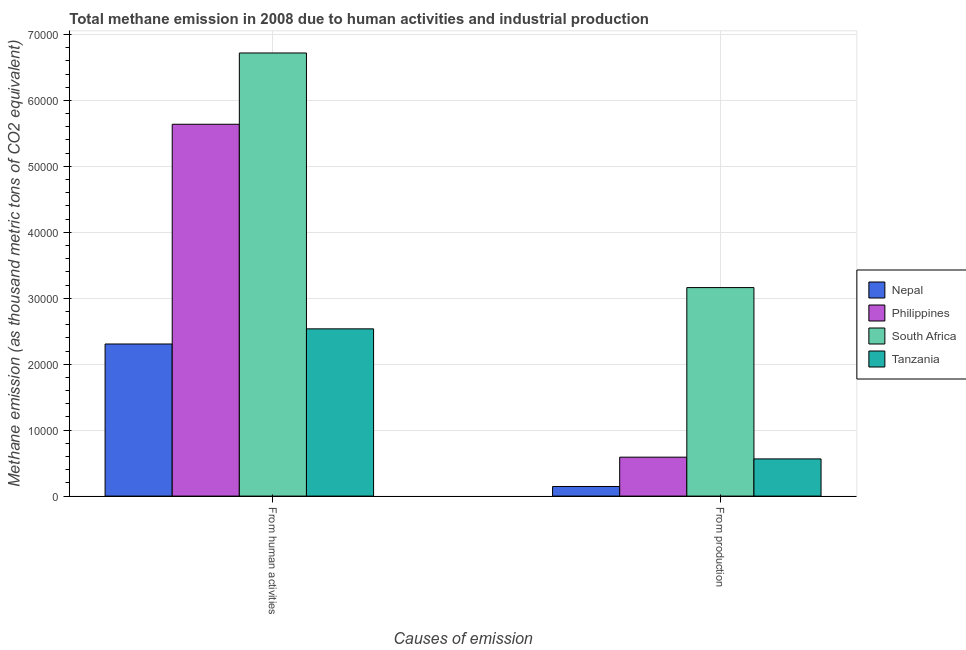How many different coloured bars are there?
Your answer should be compact. 4. Are the number of bars per tick equal to the number of legend labels?
Provide a succinct answer. Yes. Are the number of bars on each tick of the X-axis equal?
Offer a terse response. Yes. What is the label of the 2nd group of bars from the left?
Your answer should be very brief. From production. What is the amount of emissions from human activities in South Africa?
Provide a succinct answer. 6.72e+04. Across all countries, what is the maximum amount of emissions generated from industries?
Offer a terse response. 3.16e+04. Across all countries, what is the minimum amount of emissions from human activities?
Your answer should be compact. 2.31e+04. In which country was the amount of emissions from human activities maximum?
Offer a very short reply. South Africa. In which country was the amount of emissions generated from industries minimum?
Provide a succinct answer. Nepal. What is the total amount of emissions generated from industries in the graph?
Keep it short and to the point. 4.46e+04. What is the difference between the amount of emissions from human activities in Nepal and that in Philippines?
Your answer should be very brief. -3.33e+04. What is the difference between the amount of emissions from human activities in South Africa and the amount of emissions generated from industries in Nepal?
Provide a succinct answer. 6.57e+04. What is the average amount of emissions from human activities per country?
Keep it short and to the point. 4.30e+04. What is the difference between the amount of emissions generated from industries and amount of emissions from human activities in Philippines?
Make the answer very short. -5.05e+04. What is the ratio of the amount of emissions from human activities in South Africa to that in Tanzania?
Ensure brevity in your answer.  2.65. In how many countries, is the amount of emissions generated from industries greater than the average amount of emissions generated from industries taken over all countries?
Your answer should be very brief. 1. What does the 4th bar from the left in From human activities represents?
Make the answer very short. Tanzania. What does the 4th bar from the right in From human activities represents?
Keep it short and to the point. Nepal. Are all the bars in the graph horizontal?
Your answer should be compact. No. What is the difference between two consecutive major ticks on the Y-axis?
Keep it short and to the point. 10000. Are the values on the major ticks of Y-axis written in scientific E-notation?
Ensure brevity in your answer.  No. Does the graph contain grids?
Your answer should be very brief. Yes. Where does the legend appear in the graph?
Make the answer very short. Center right. How many legend labels are there?
Make the answer very short. 4. What is the title of the graph?
Keep it short and to the point. Total methane emission in 2008 due to human activities and industrial production. Does "Myanmar" appear as one of the legend labels in the graph?
Offer a very short reply. No. What is the label or title of the X-axis?
Keep it short and to the point. Causes of emission. What is the label or title of the Y-axis?
Your answer should be compact. Methane emission (as thousand metric tons of CO2 equivalent). What is the Methane emission (as thousand metric tons of CO2 equivalent) of Nepal in From human activities?
Provide a succinct answer. 2.31e+04. What is the Methane emission (as thousand metric tons of CO2 equivalent) in Philippines in From human activities?
Your answer should be very brief. 5.64e+04. What is the Methane emission (as thousand metric tons of CO2 equivalent) in South Africa in From human activities?
Provide a succinct answer. 6.72e+04. What is the Methane emission (as thousand metric tons of CO2 equivalent) of Tanzania in From human activities?
Ensure brevity in your answer.  2.54e+04. What is the Methane emission (as thousand metric tons of CO2 equivalent) of Nepal in From production?
Your response must be concise. 1458.6. What is the Methane emission (as thousand metric tons of CO2 equivalent) of Philippines in From production?
Give a very brief answer. 5905.9. What is the Methane emission (as thousand metric tons of CO2 equivalent) of South Africa in From production?
Your answer should be very brief. 3.16e+04. What is the Methane emission (as thousand metric tons of CO2 equivalent) in Tanzania in From production?
Offer a very short reply. 5639.9. Across all Causes of emission, what is the maximum Methane emission (as thousand metric tons of CO2 equivalent) of Nepal?
Offer a terse response. 2.31e+04. Across all Causes of emission, what is the maximum Methane emission (as thousand metric tons of CO2 equivalent) in Philippines?
Your answer should be compact. 5.64e+04. Across all Causes of emission, what is the maximum Methane emission (as thousand metric tons of CO2 equivalent) in South Africa?
Give a very brief answer. 6.72e+04. Across all Causes of emission, what is the maximum Methane emission (as thousand metric tons of CO2 equivalent) of Tanzania?
Offer a very short reply. 2.54e+04. Across all Causes of emission, what is the minimum Methane emission (as thousand metric tons of CO2 equivalent) of Nepal?
Your answer should be very brief. 1458.6. Across all Causes of emission, what is the minimum Methane emission (as thousand metric tons of CO2 equivalent) of Philippines?
Provide a short and direct response. 5905.9. Across all Causes of emission, what is the minimum Methane emission (as thousand metric tons of CO2 equivalent) of South Africa?
Keep it short and to the point. 3.16e+04. Across all Causes of emission, what is the minimum Methane emission (as thousand metric tons of CO2 equivalent) in Tanzania?
Your answer should be compact. 5639.9. What is the total Methane emission (as thousand metric tons of CO2 equivalent) of Nepal in the graph?
Offer a terse response. 2.45e+04. What is the total Methane emission (as thousand metric tons of CO2 equivalent) of Philippines in the graph?
Keep it short and to the point. 6.23e+04. What is the total Methane emission (as thousand metric tons of CO2 equivalent) of South Africa in the graph?
Your response must be concise. 9.88e+04. What is the total Methane emission (as thousand metric tons of CO2 equivalent) of Tanzania in the graph?
Offer a terse response. 3.10e+04. What is the difference between the Methane emission (as thousand metric tons of CO2 equivalent) in Nepal in From human activities and that in From production?
Keep it short and to the point. 2.16e+04. What is the difference between the Methane emission (as thousand metric tons of CO2 equivalent) of Philippines in From human activities and that in From production?
Provide a short and direct response. 5.05e+04. What is the difference between the Methane emission (as thousand metric tons of CO2 equivalent) in South Africa in From human activities and that in From production?
Offer a terse response. 3.56e+04. What is the difference between the Methane emission (as thousand metric tons of CO2 equivalent) of Tanzania in From human activities and that in From production?
Your answer should be compact. 1.97e+04. What is the difference between the Methane emission (as thousand metric tons of CO2 equivalent) of Nepal in From human activities and the Methane emission (as thousand metric tons of CO2 equivalent) of Philippines in From production?
Offer a very short reply. 1.72e+04. What is the difference between the Methane emission (as thousand metric tons of CO2 equivalent) in Nepal in From human activities and the Methane emission (as thousand metric tons of CO2 equivalent) in South Africa in From production?
Keep it short and to the point. -8551.5. What is the difference between the Methane emission (as thousand metric tons of CO2 equivalent) in Nepal in From human activities and the Methane emission (as thousand metric tons of CO2 equivalent) in Tanzania in From production?
Your answer should be compact. 1.74e+04. What is the difference between the Methane emission (as thousand metric tons of CO2 equivalent) in Philippines in From human activities and the Methane emission (as thousand metric tons of CO2 equivalent) in South Africa in From production?
Offer a very short reply. 2.48e+04. What is the difference between the Methane emission (as thousand metric tons of CO2 equivalent) of Philippines in From human activities and the Methane emission (as thousand metric tons of CO2 equivalent) of Tanzania in From production?
Your answer should be compact. 5.07e+04. What is the difference between the Methane emission (as thousand metric tons of CO2 equivalent) of South Africa in From human activities and the Methane emission (as thousand metric tons of CO2 equivalent) of Tanzania in From production?
Offer a very short reply. 6.15e+04. What is the average Methane emission (as thousand metric tons of CO2 equivalent) in Nepal per Causes of emission?
Offer a terse response. 1.23e+04. What is the average Methane emission (as thousand metric tons of CO2 equivalent) in Philippines per Causes of emission?
Ensure brevity in your answer.  3.11e+04. What is the average Methane emission (as thousand metric tons of CO2 equivalent) in South Africa per Causes of emission?
Your answer should be compact. 4.94e+04. What is the average Methane emission (as thousand metric tons of CO2 equivalent) of Tanzania per Causes of emission?
Your answer should be very brief. 1.55e+04. What is the difference between the Methane emission (as thousand metric tons of CO2 equivalent) of Nepal and Methane emission (as thousand metric tons of CO2 equivalent) of Philippines in From human activities?
Provide a short and direct response. -3.33e+04. What is the difference between the Methane emission (as thousand metric tons of CO2 equivalent) in Nepal and Methane emission (as thousand metric tons of CO2 equivalent) in South Africa in From human activities?
Make the answer very short. -4.41e+04. What is the difference between the Methane emission (as thousand metric tons of CO2 equivalent) of Nepal and Methane emission (as thousand metric tons of CO2 equivalent) of Tanzania in From human activities?
Your answer should be compact. -2295.7. What is the difference between the Methane emission (as thousand metric tons of CO2 equivalent) in Philippines and Methane emission (as thousand metric tons of CO2 equivalent) in South Africa in From human activities?
Ensure brevity in your answer.  -1.08e+04. What is the difference between the Methane emission (as thousand metric tons of CO2 equivalent) in Philippines and Methane emission (as thousand metric tons of CO2 equivalent) in Tanzania in From human activities?
Your answer should be compact. 3.10e+04. What is the difference between the Methane emission (as thousand metric tons of CO2 equivalent) of South Africa and Methane emission (as thousand metric tons of CO2 equivalent) of Tanzania in From human activities?
Offer a terse response. 4.18e+04. What is the difference between the Methane emission (as thousand metric tons of CO2 equivalent) of Nepal and Methane emission (as thousand metric tons of CO2 equivalent) of Philippines in From production?
Provide a short and direct response. -4447.3. What is the difference between the Methane emission (as thousand metric tons of CO2 equivalent) in Nepal and Methane emission (as thousand metric tons of CO2 equivalent) in South Africa in From production?
Provide a short and direct response. -3.02e+04. What is the difference between the Methane emission (as thousand metric tons of CO2 equivalent) in Nepal and Methane emission (as thousand metric tons of CO2 equivalent) in Tanzania in From production?
Give a very brief answer. -4181.3. What is the difference between the Methane emission (as thousand metric tons of CO2 equivalent) of Philippines and Methane emission (as thousand metric tons of CO2 equivalent) of South Africa in From production?
Your answer should be compact. -2.57e+04. What is the difference between the Methane emission (as thousand metric tons of CO2 equivalent) of Philippines and Methane emission (as thousand metric tons of CO2 equivalent) of Tanzania in From production?
Your response must be concise. 266. What is the difference between the Methane emission (as thousand metric tons of CO2 equivalent) in South Africa and Methane emission (as thousand metric tons of CO2 equivalent) in Tanzania in From production?
Your response must be concise. 2.60e+04. What is the ratio of the Methane emission (as thousand metric tons of CO2 equivalent) in Nepal in From human activities to that in From production?
Offer a terse response. 15.81. What is the ratio of the Methane emission (as thousand metric tons of CO2 equivalent) of Philippines in From human activities to that in From production?
Provide a short and direct response. 9.55. What is the ratio of the Methane emission (as thousand metric tons of CO2 equivalent) in South Africa in From human activities to that in From production?
Your answer should be compact. 2.13. What is the ratio of the Methane emission (as thousand metric tons of CO2 equivalent) in Tanzania in From human activities to that in From production?
Your response must be concise. 4.5. What is the difference between the highest and the second highest Methane emission (as thousand metric tons of CO2 equivalent) of Nepal?
Offer a terse response. 2.16e+04. What is the difference between the highest and the second highest Methane emission (as thousand metric tons of CO2 equivalent) in Philippines?
Your answer should be very brief. 5.05e+04. What is the difference between the highest and the second highest Methane emission (as thousand metric tons of CO2 equivalent) of South Africa?
Offer a very short reply. 3.56e+04. What is the difference between the highest and the second highest Methane emission (as thousand metric tons of CO2 equivalent) in Tanzania?
Keep it short and to the point. 1.97e+04. What is the difference between the highest and the lowest Methane emission (as thousand metric tons of CO2 equivalent) in Nepal?
Make the answer very short. 2.16e+04. What is the difference between the highest and the lowest Methane emission (as thousand metric tons of CO2 equivalent) in Philippines?
Keep it short and to the point. 5.05e+04. What is the difference between the highest and the lowest Methane emission (as thousand metric tons of CO2 equivalent) in South Africa?
Give a very brief answer. 3.56e+04. What is the difference between the highest and the lowest Methane emission (as thousand metric tons of CO2 equivalent) of Tanzania?
Ensure brevity in your answer.  1.97e+04. 